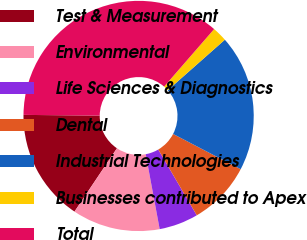Convert chart to OTSL. <chart><loc_0><loc_0><loc_500><loc_500><pie_chart><fcel>Test & Measurement<fcel>Environmental<fcel>Life Sciences & Diagnostics<fcel>Dental<fcel>Industrial Technologies<fcel>Businesses contributed to Apex<fcel>Total<nl><fcel>15.75%<fcel>12.33%<fcel>5.5%<fcel>8.92%<fcel>19.17%<fcel>2.09%<fcel>36.24%<nl></chart> 